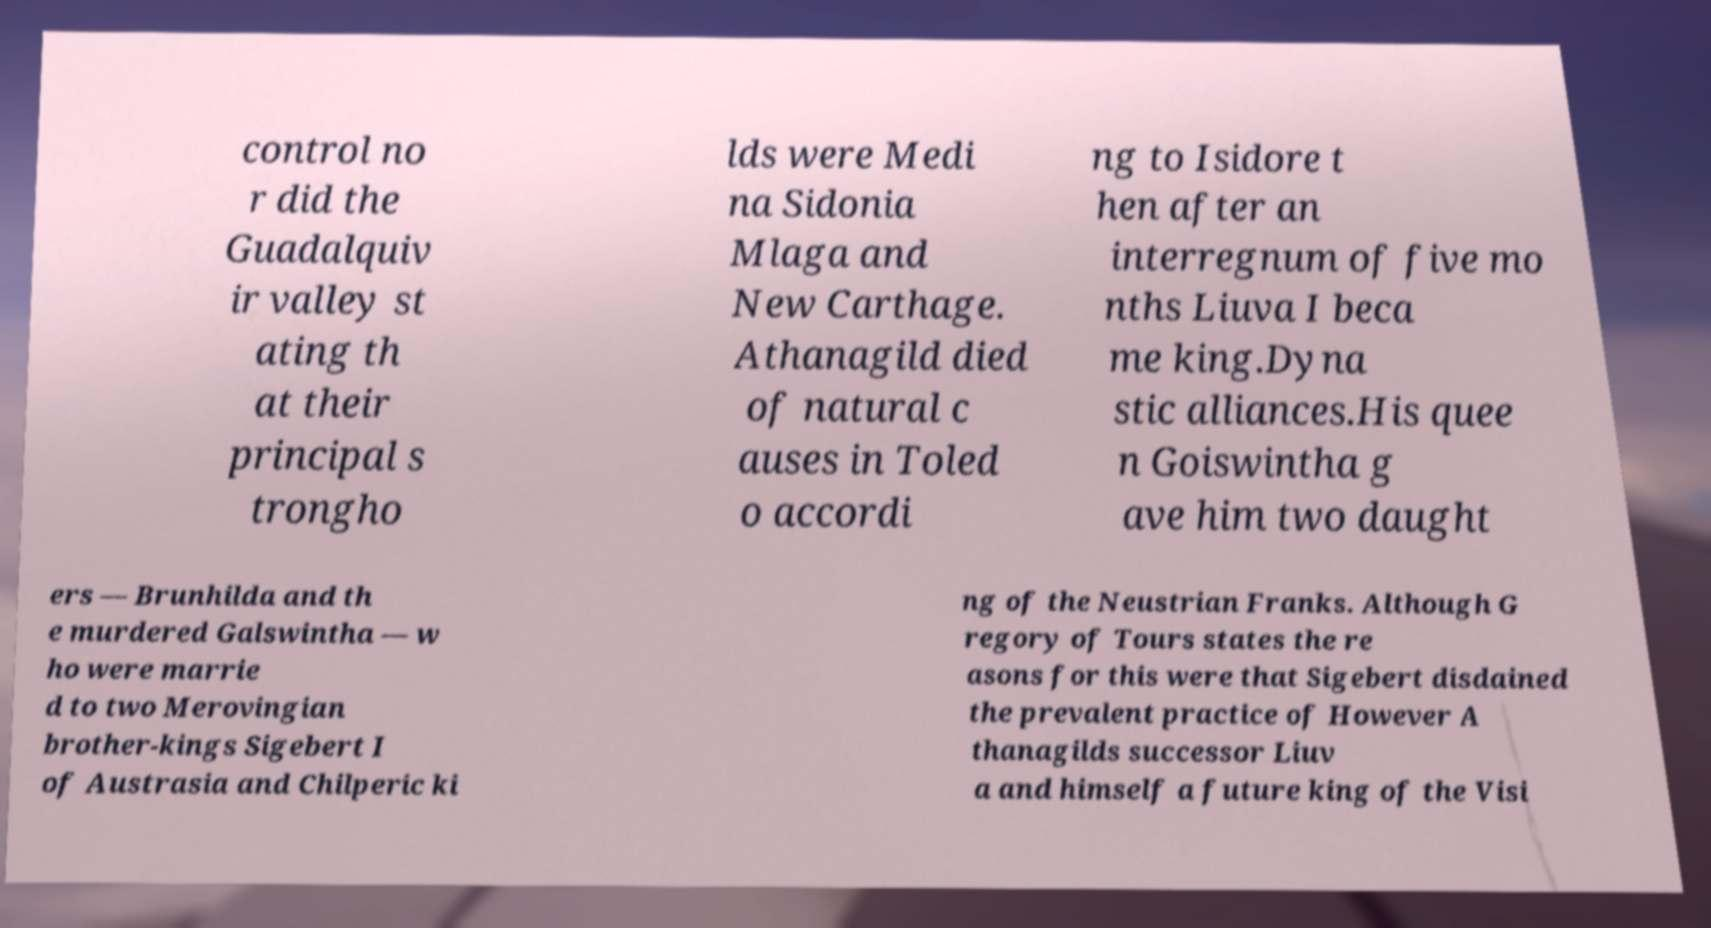There's text embedded in this image that I need extracted. Can you transcribe it verbatim? control no r did the Guadalquiv ir valley st ating th at their principal s trongho lds were Medi na Sidonia Mlaga and New Carthage. Athanagild died of natural c auses in Toled o accordi ng to Isidore t hen after an interregnum of five mo nths Liuva I beca me king.Dyna stic alliances.His quee n Goiswintha g ave him two daught ers — Brunhilda and th e murdered Galswintha — w ho were marrie d to two Merovingian brother-kings Sigebert I of Austrasia and Chilperic ki ng of the Neustrian Franks. Although G regory of Tours states the re asons for this were that Sigebert disdained the prevalent practice of However A thanagilds successor Liuv a and himself a future king of the Visi 